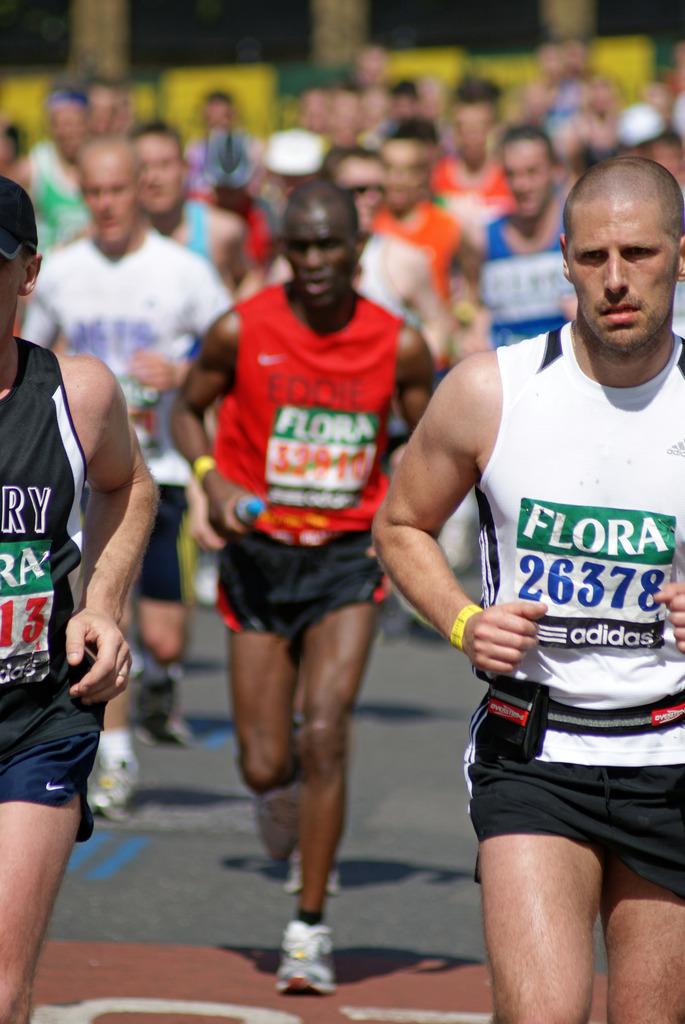What athletic brand is advertised on the man in the white shirt?
Offer a terse response. Adidas. 